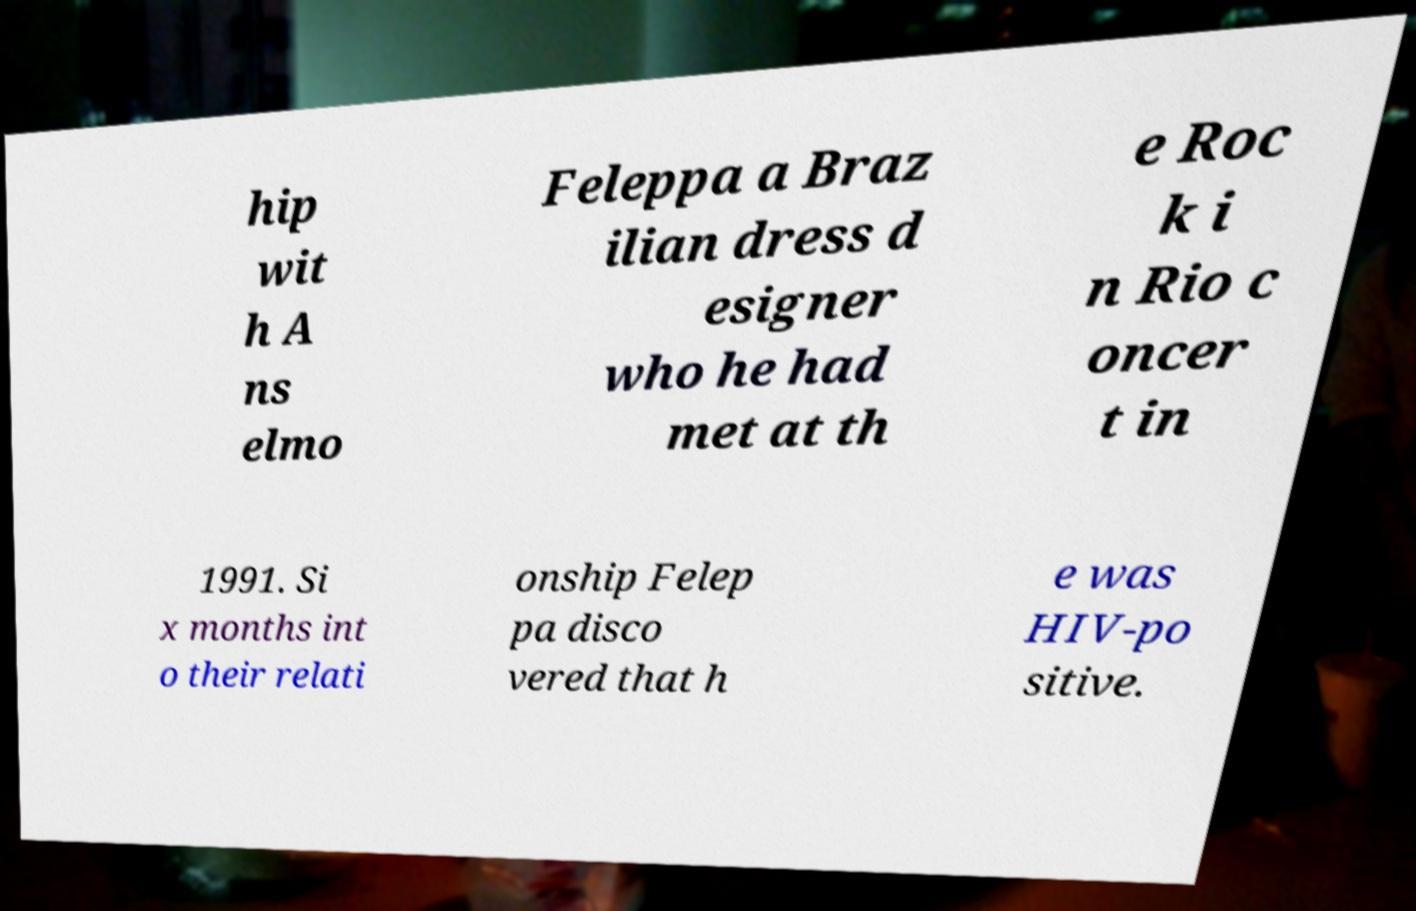For documentation purposes, I need the text within this image transcribed. Could you provide that? hip wit h A ns elmo Feleppa a Braz ilian dress d esigner who he had met at th e Roc k i n Rio c oncer t in 1991. Si x months int o their relati onship Felep pa disco vered that h e was HIV-po sitive. 